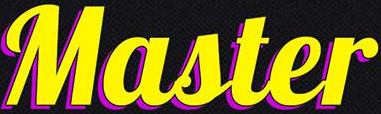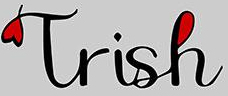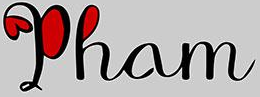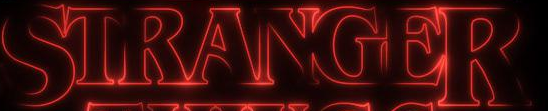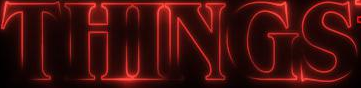Identify the words shown in these images in order, separated by a semicolon. Master; Trish; Pham; STRANGER; THINGS 